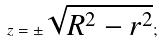<formula> <loc_0><loc_0><loc_500><loc_500>z = \pm \sqrt { R ^ { 2 } - r ^ { 2 } } ;</formula> 